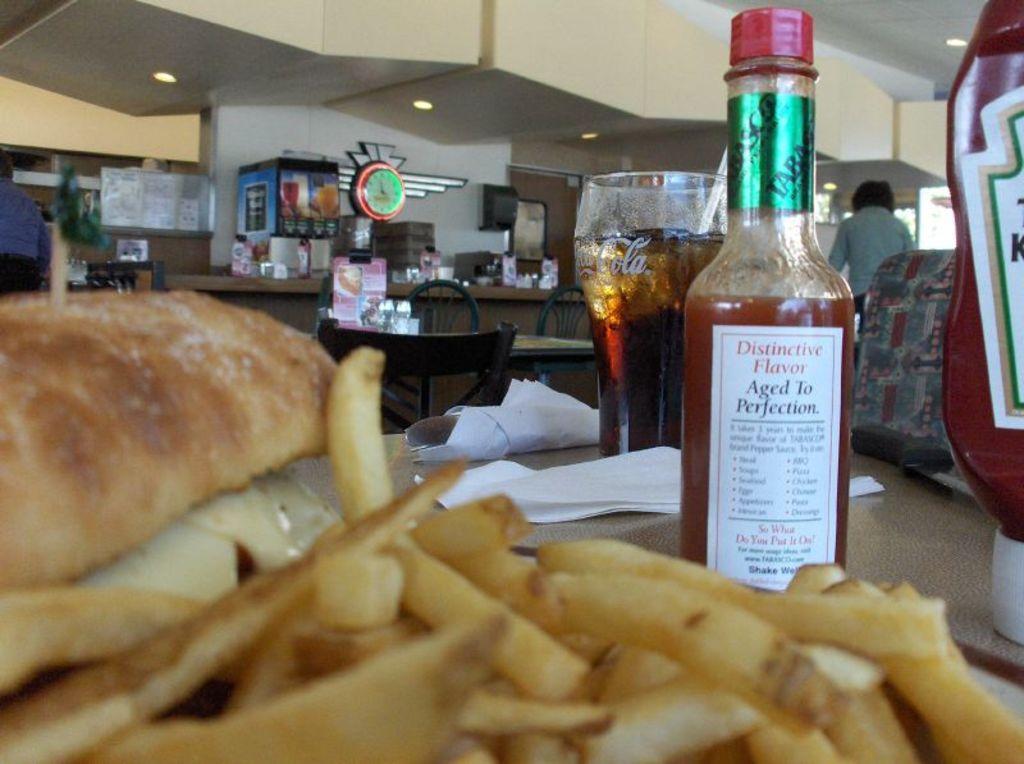Can you describe this image briefly? Here we can see a sauce bottle and french fries and glass and some objects on it, and here is the dining table and some objects on it, and here is the wall. 